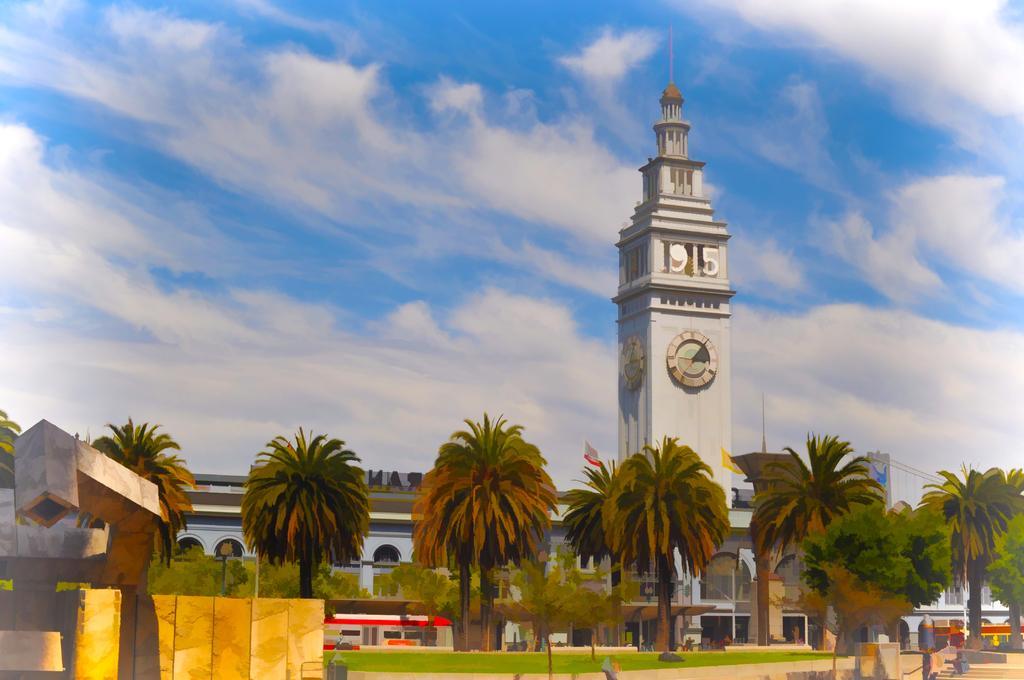How would you summarize this image in a sentence or two? This is a painting. In this there are trees. In the back there is a building with a clock tower. In the background there is sky with clouds. On the left side there is a wall. 